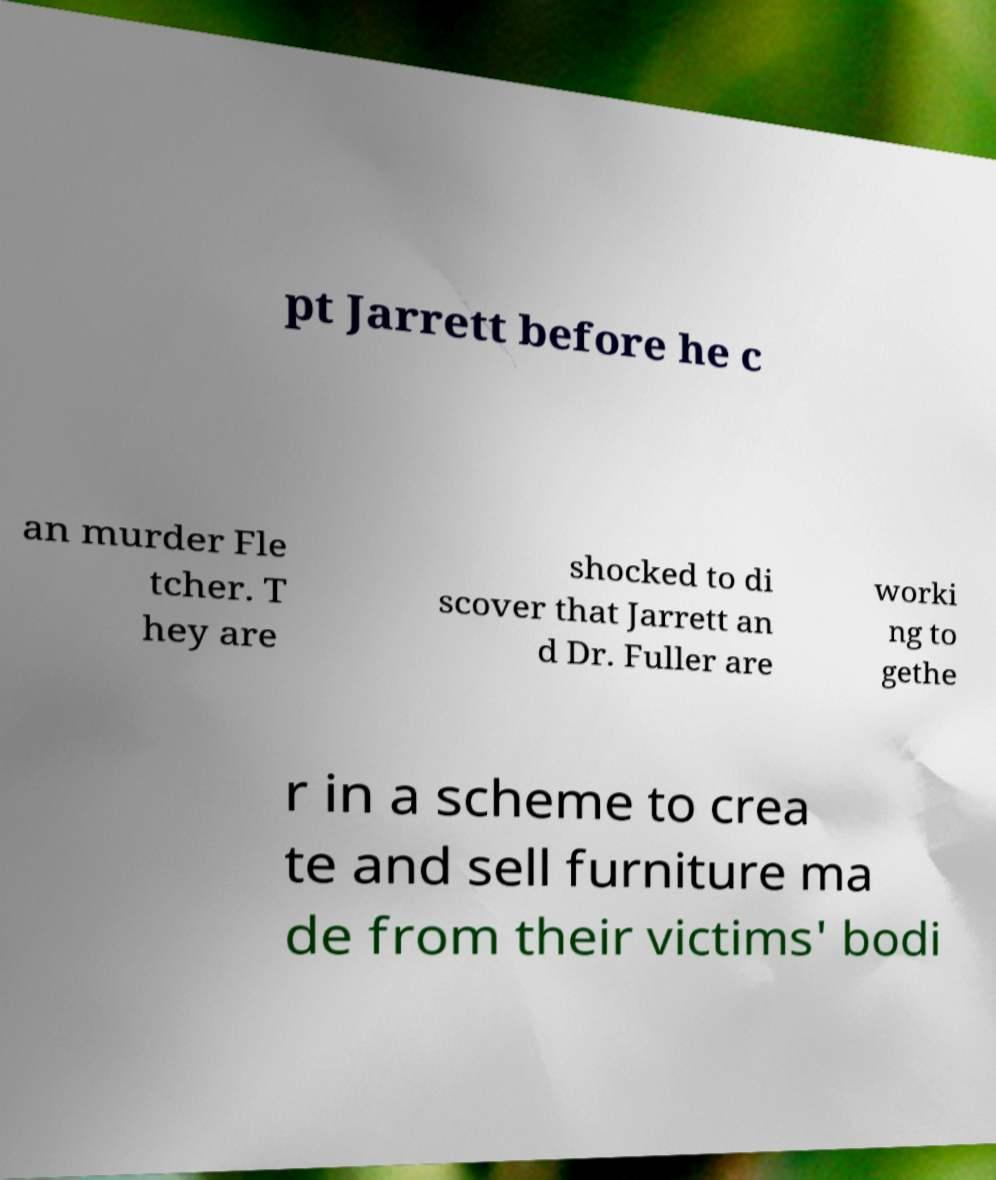Could you assist in decoding the text presented in this image and type it out clearly? pt Jarrett before he c an murder Fle tcher. T hey are shocked to di scover that Jarrett an d Dr. Fuller are worki ng to gethe r in a scheme to crea te and sell furniture ma de from their victims' bodi 